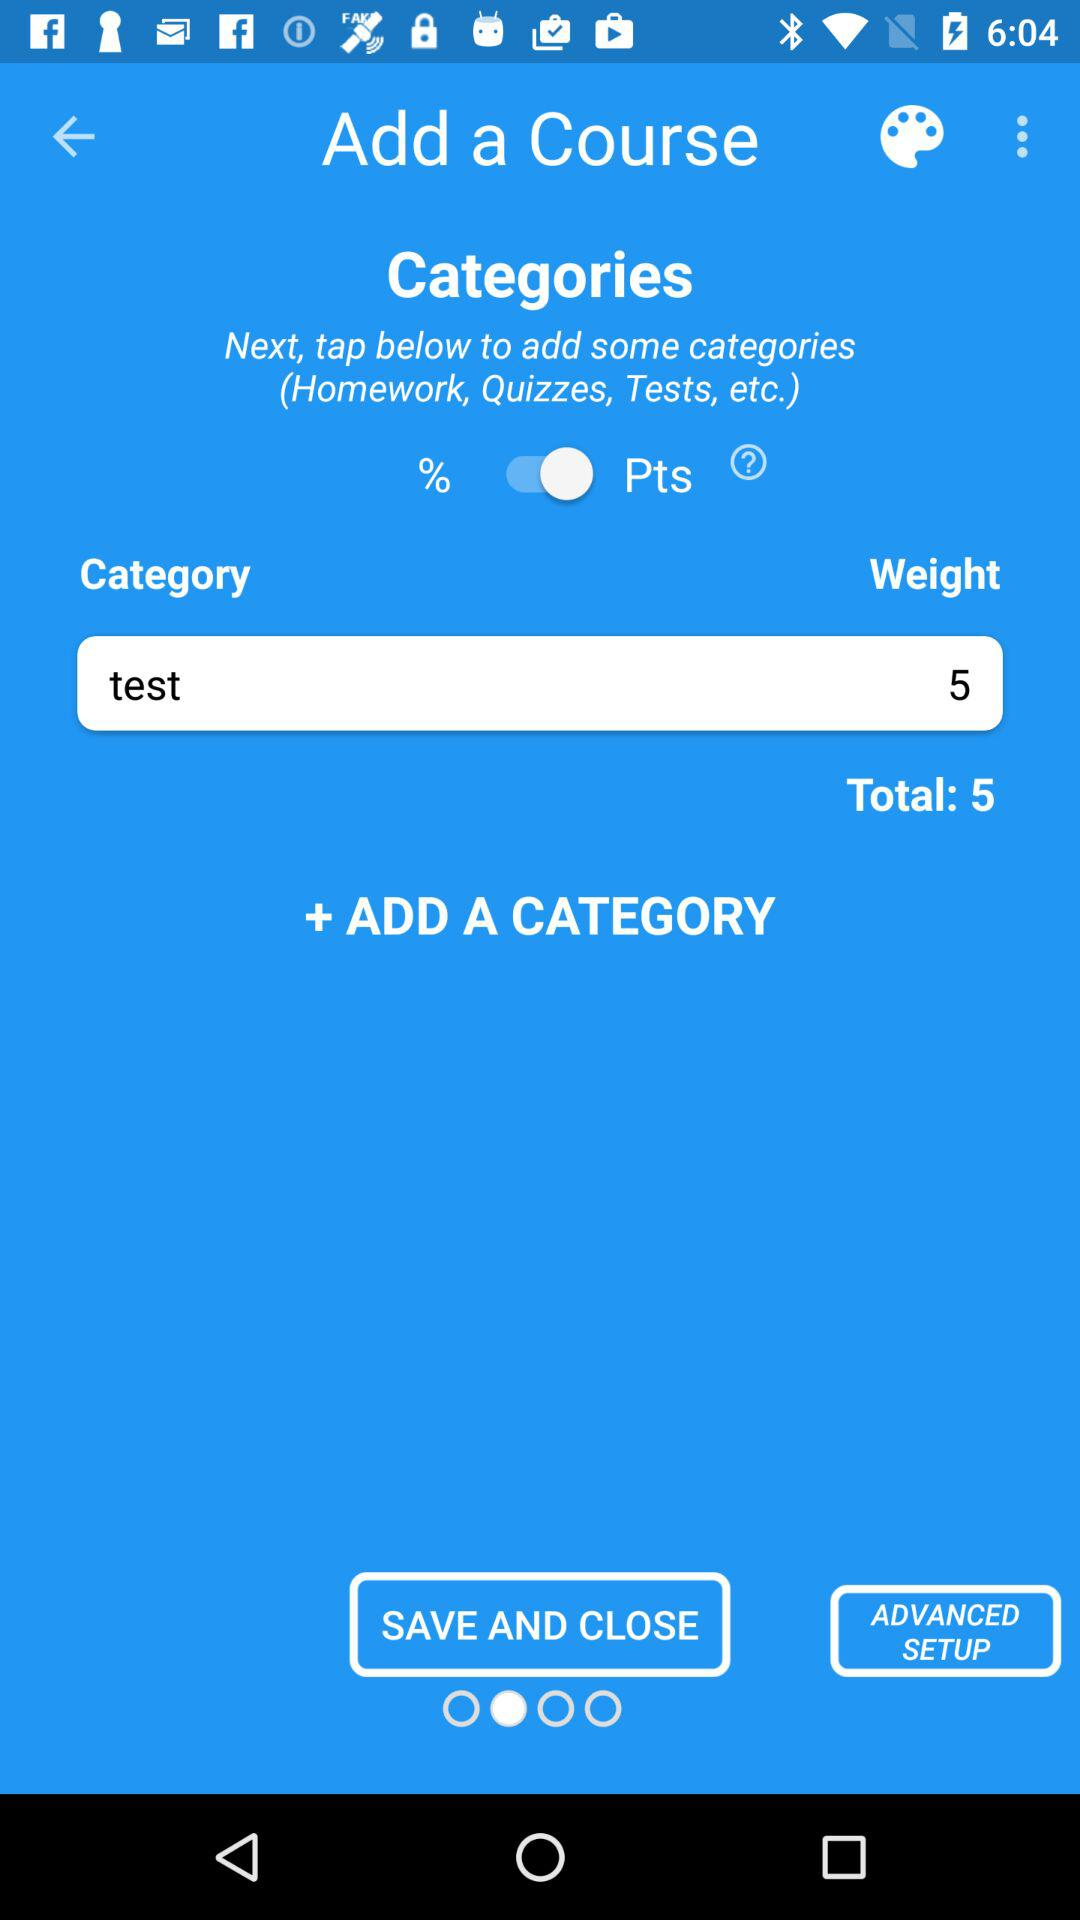What is the selected "Weight"? The selected "Weight" is 5. 